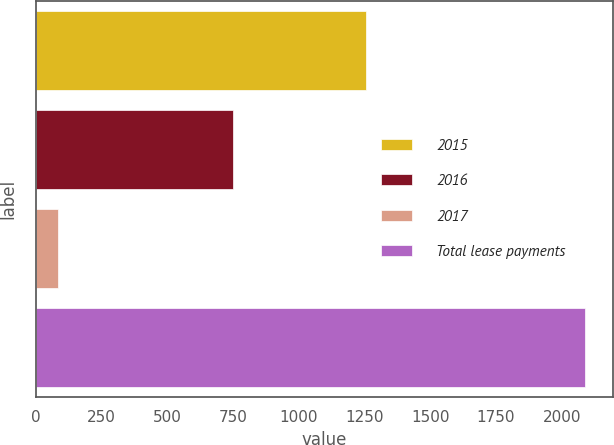Convert chart to OTSL. <chart><loc_0><loc_0><loc_500><loc_500><bar_chart><fcel>2015<fcel>2016<fcel>2017<fcel>Total lease payments<nl><fcel>1256<fcel>750<fcel>84<fcel>2090<nl></chart> 